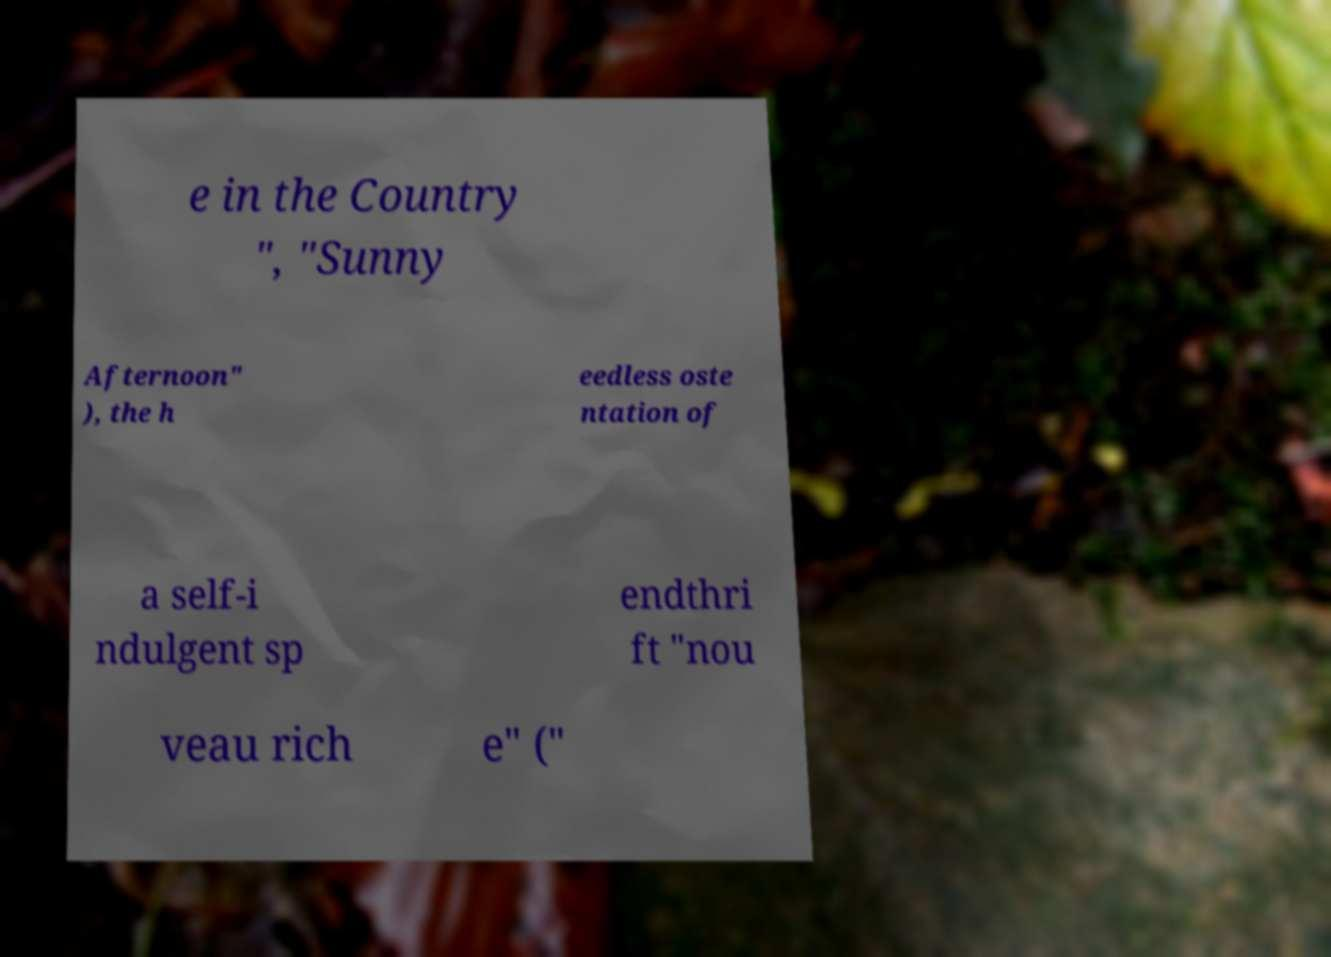I need the written content from this picture converted into text. Can you do that? e in the Country ", "Sunny Afternoon" ), the h eedless oste ntation of a self-i ndulgent sp endthri ft "nou veau rich e" (" 